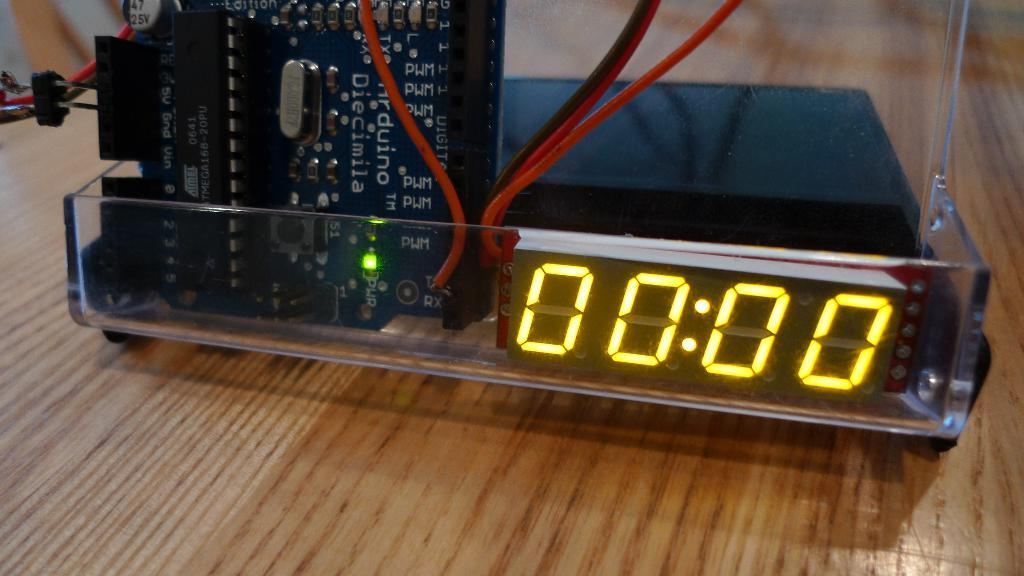Provide a one-sentence caption for the provided image. In a plastic case, an Arduino micro controller drives a display. 